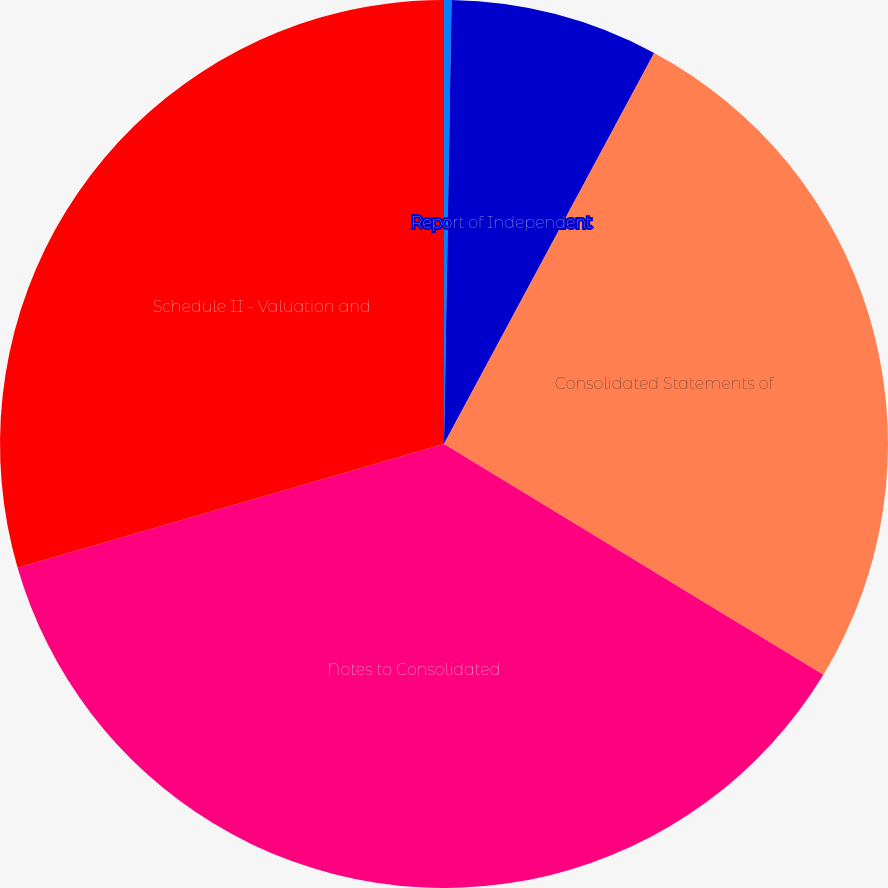<chart> <loc_0><loc_0><loc_500><loc_500><pie_chart><fcel>Management's Report on<fcel>Report of Independent<fcel>Consolidated Statements of<fcel>Notes to Consolidated<fcel>Schedule II - Valuation and<nl><fcel>0.27%<fcel>7.58%<fcel>25.85%<fcel>36.81%<fcel>29.5%<nl></chart> 